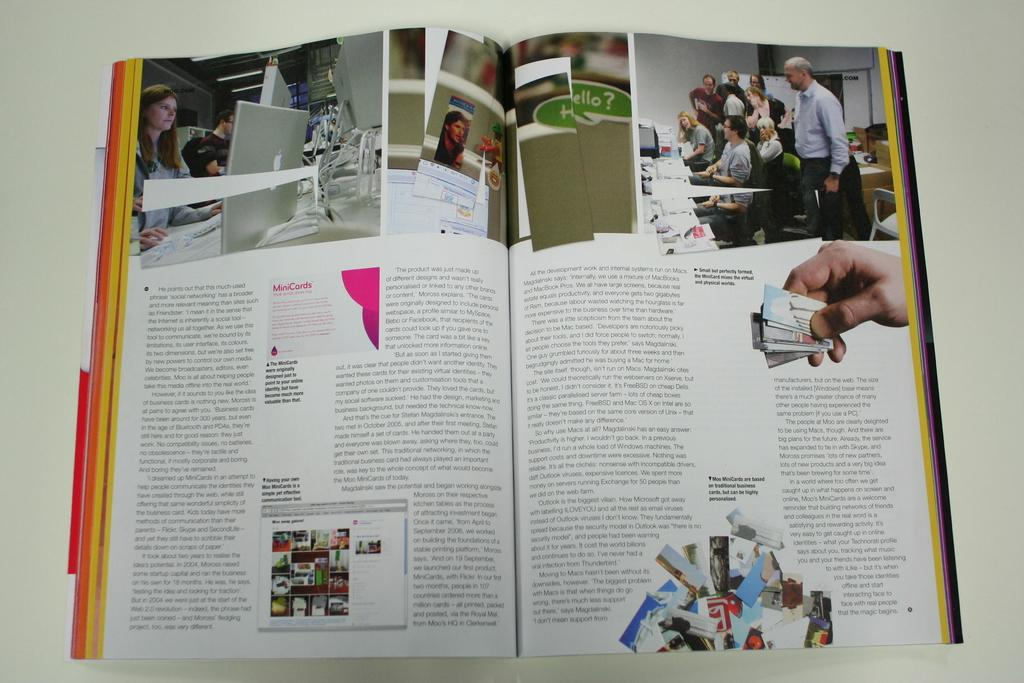<image>
Render a clear and concise summary of the photo. A magazine page starts with the word "He". 